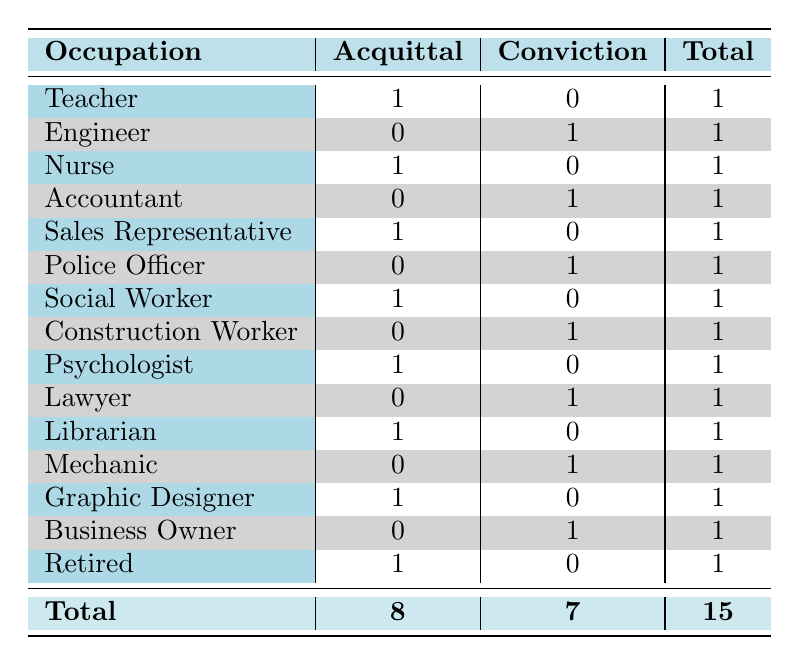What is the total number of jurors in favor of acquittal? By looking at the column under "Acquittal," we can see that there are 8 instances of jurors favoring an acquittal verdict.
Answer: 8 How many jurors who are police officers are in favor of a conviction? In the table, there is one juror listed as a police officer, and their verdict tendency is "Conviction."
Answer: 1 What is the difference between the number of jurors favoring acquittal versus those favoring conviction? There are 8 jurors favoring acquittal and 7 jurors favoring conviction. The difference is calculated as 8 - 7 = 1.
Answer: 1 Is there more jurors favoring acquittal from the occupation of Social Worker compared to Business Owner? A Social Worker has 1 juror favoring acquittal, while a Business Owner has 0 favoring acquittal. Thus, there are more jurors favoring acquittal from Social Worker.
Answer: Yes What percentage of the total jurors are in favor of a conviction? To find the percentage, we take the number of jurors in favor of conviction (7) divided by the total number of jurors (15), which gives us 7/15. Multiplying by 100 to get the percentage, we get approximately 46.67%.
Answer: 46.67% How many occupations are represented in the table that have only one juror's verdict? All occupations listed have one vote for either acquittal or conviction, totaling 15 different occupations represented in the table.
Answer: 15 Which occupation type has the most jurors favoring acquittal? Upon reviewing each occupation, multiple types have the same single count. However, since the question asks for the most, any of them that favor acquittal collectively present a maximum of 1 count each.
Answer: Each of them is equal with 1 What is the total number of convictions from those who are engineers or accountants? The table shows that there is one conviction from an Engineer and one conviction from an Accountant, giving a total of 1 + 1 = 2.
Answer: 2 How many more acquittals are there compared to convictions in the category of Health-related professions? The Health-related professions are Nurse and Psychologist, both favoring acquittal (2). There are no convictions in this profession category, resulting in 2 - 0 = 2 more acquittals.
Answer: 2 